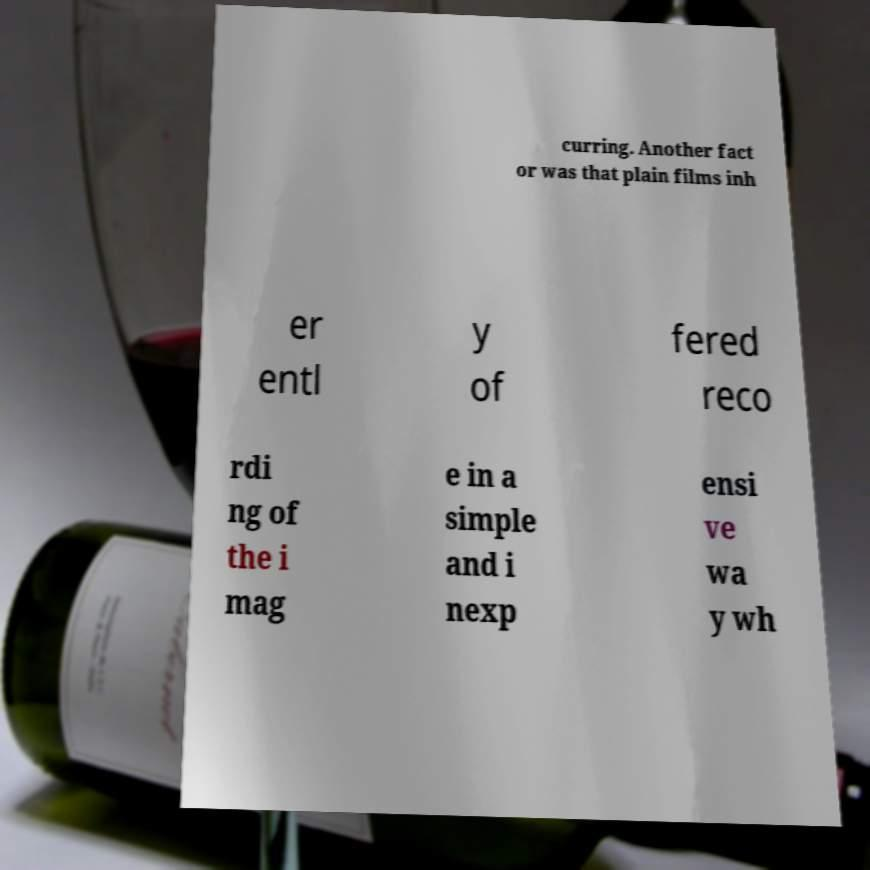Please read and relay the text visible in this image. What does it say? curring. Another fact or was that plain films inh er entl y of fered reco rdi ng of the i mag e in a simple and i nexp ensi ve wa y wh 